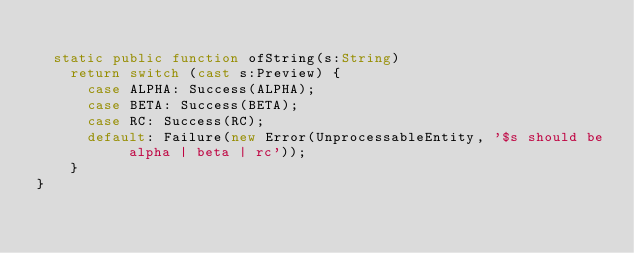<code> <loc_0><loc_0><loc_500><loc_500><_Haxe_>
  static public function ofString(s:String) 
    return switch (cast s:Preview) {
      case ALPHA: Success(ALPHA);
      case BETA: Success(BETA);
      case RC: Success(RC);
      default: Failure(new Error(UnprocessableEntity, '$s should be alpha | beta | rc'));
    }
}
</code> 